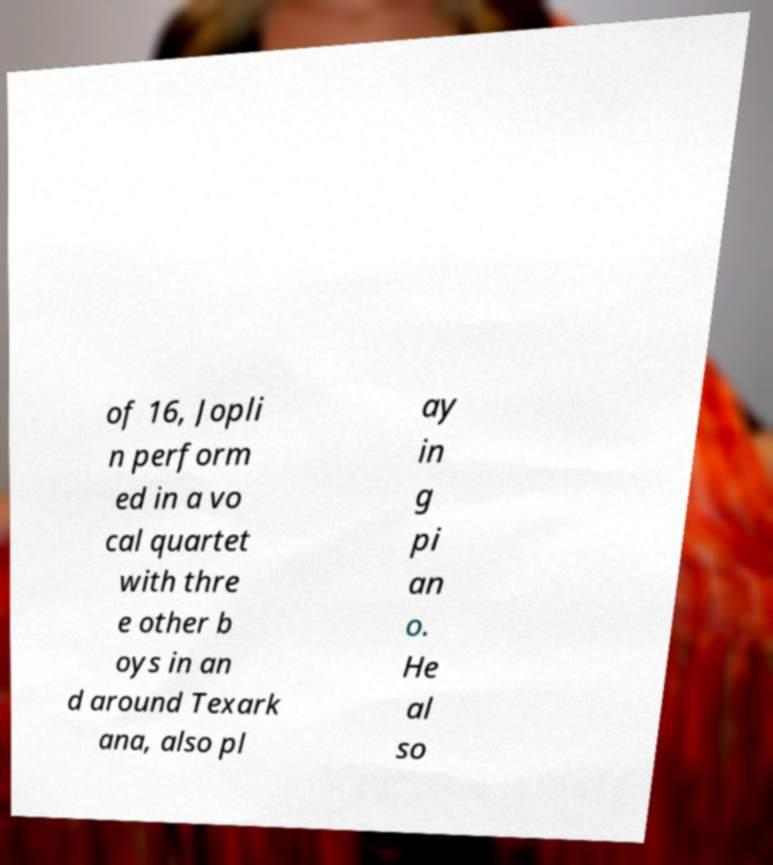There's text embedded in this image that I need extracted. Can you transcribe it verbatim? of 16, Jopli n perform ed in a vo cal quartet with thre e other b oys in an d around Texark ana, also pl ay in g pi an o. He al so 